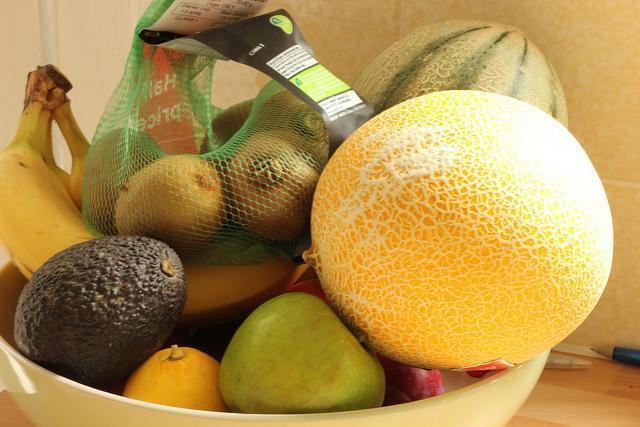How many apples are there?
Give a very brief answer. 1. 